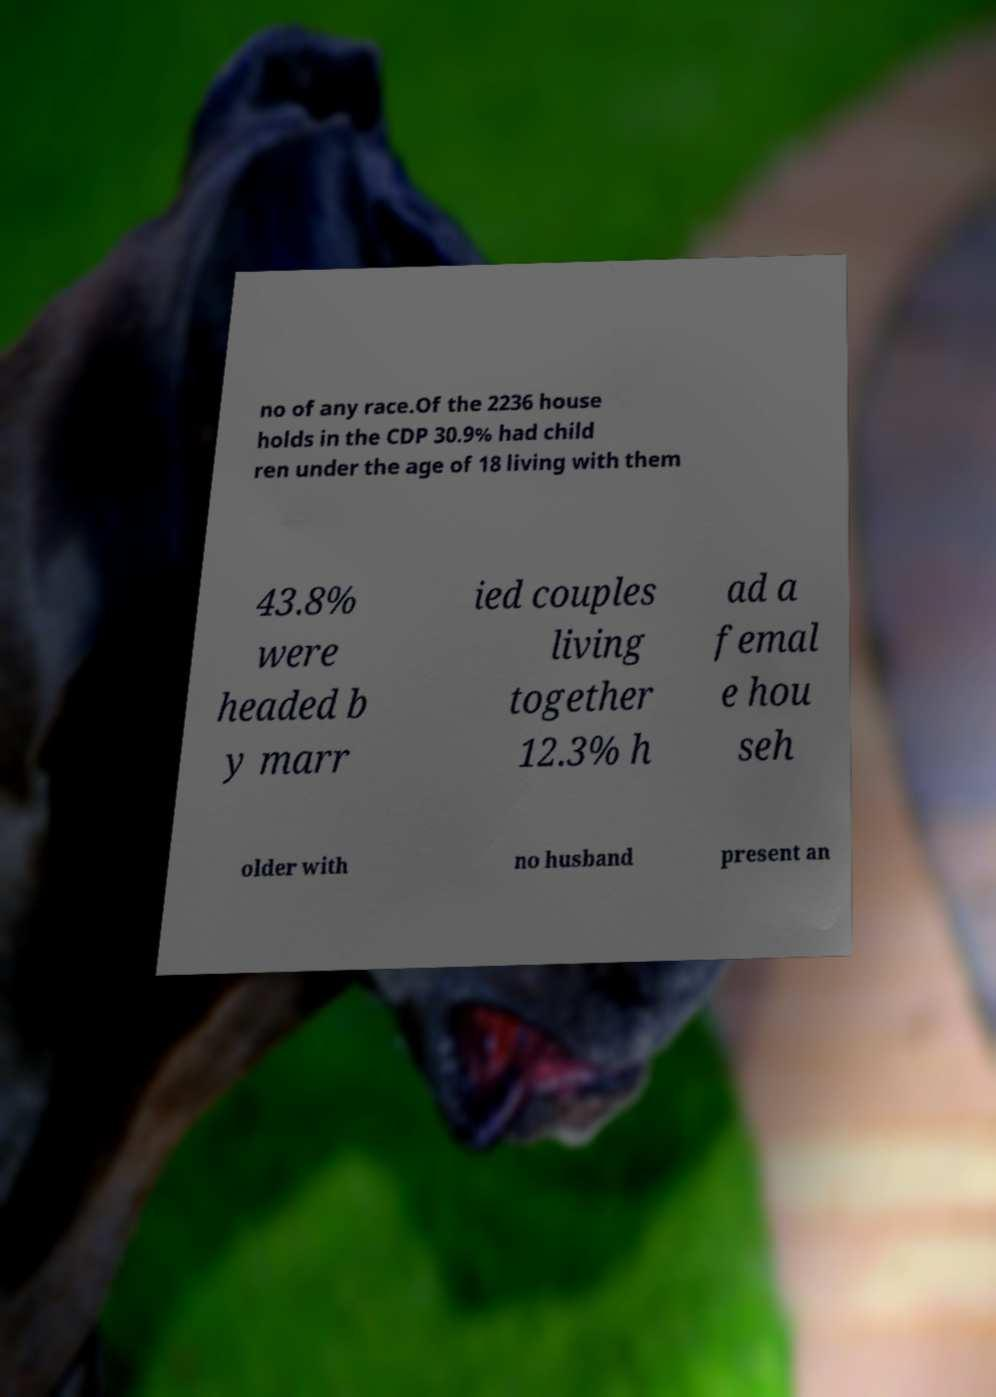There's text embedded in this image that I need extracted. Can you transcribe it verbatim? no of any race.Of the 2236 house holds in the CDP 30.9% had child ren under the age of 18 living with them 43.8% were headed b y marr ied couples living together 12.3% h ad a femal e hou seh older with no husband present an 